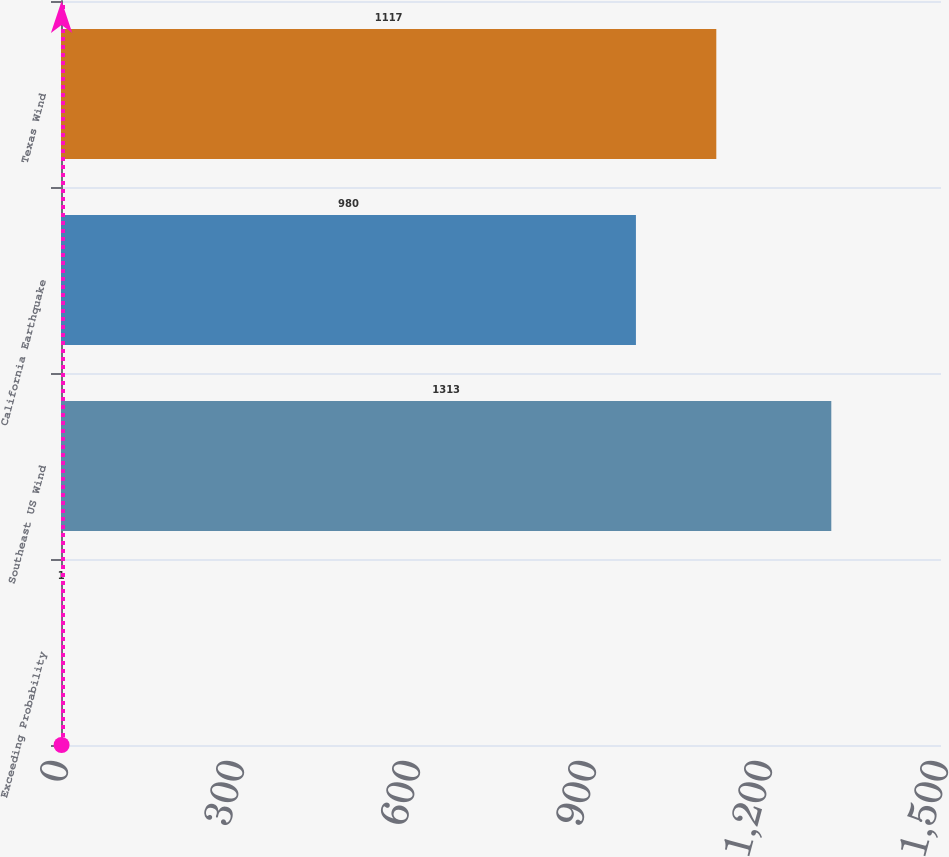Convert chart to OTSL. <chart><loc_0><loc_0><loc_500><loc_500><bar_chart><fcel>Exceeding Probability<fcel>Southeast US Wind<fcel>California Earthquake<fcel>Texas Wind<nl><fcel>1<fcel>1313<fcel>980<fcel>1117<nl></chart> 